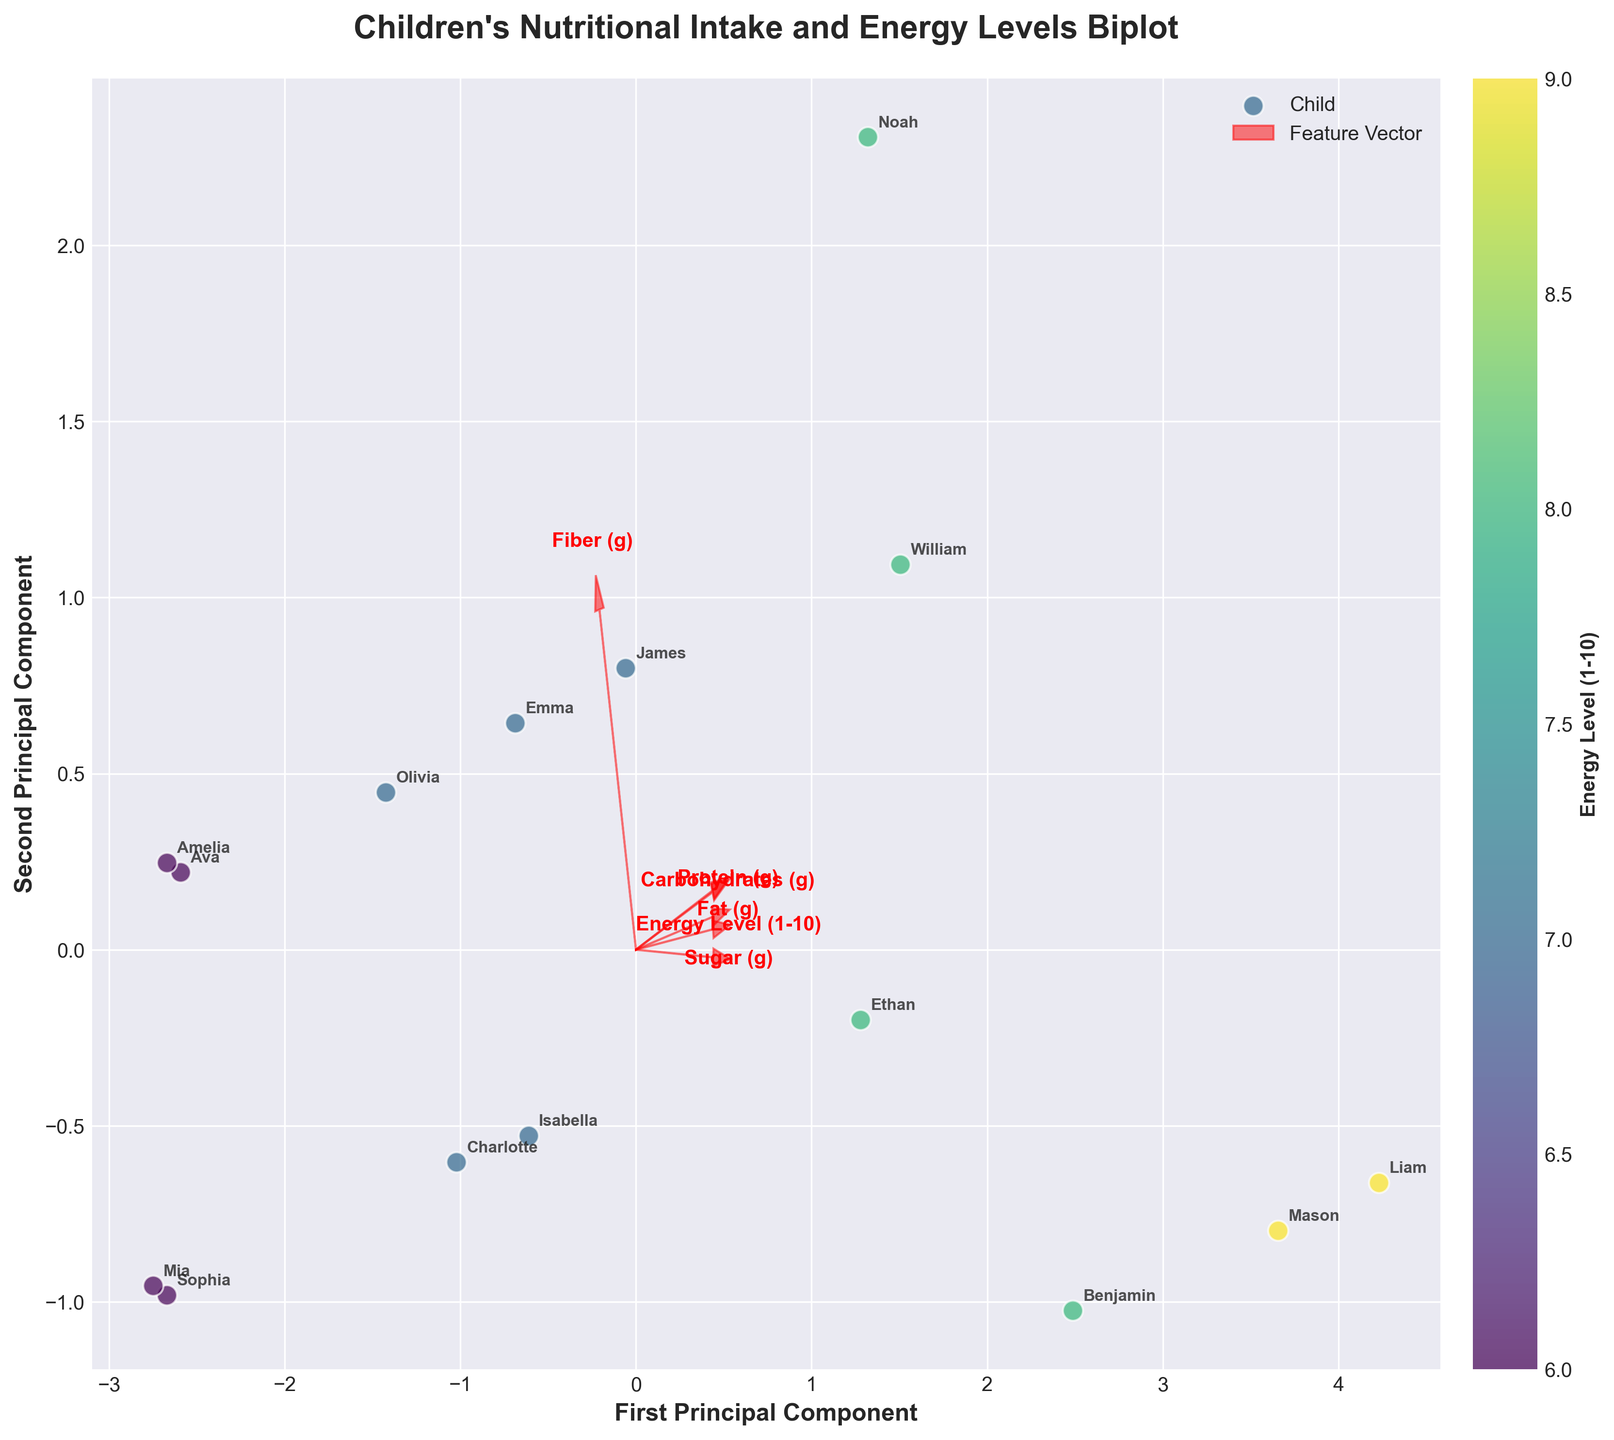How many children are represented in the plot? Count the number of individual data points (dots) in the biplot.
Answer: 15 What are the axes labels on the plot? The labels on the x-axis and y-axis can be read directly from the plot. They describe what each axis represents.
Answer: First Principal Component, Second Principal Component Which child's data point is furthest to the right on the plot? Locate the data point positioned furthest to the right along the x-axis (First Principal Component).
Answer: Liam Which feature has the longest vector (arrow) on the biplot? Compare the lengths of the arrows representing each feature. The longest arrow indicates the strongest variance explained by that feature.
Answer: Carbohydrates (g) Does sugar intake seem strongly associated with energy levels? Observe the direction and length of the arrow representing sugar intake in relation to the clustering of data points with high energy levels (indicated by color).
Answer: Yes Which two features seem to be most closely aligned in their direction on the biplot? Identify arrows that point in similar directions, indicating a strong relationship between those features.
Answer: Protein (g) and Fat (g) Are children with higher energy levels clustered together in the plot? Look at the data points with colors representing higher energy levels and see if they appear close to each other on the plot.
Answer: Yes What is the spread of children’s data points along the first principal component? Measure how much the data points are spread out along the x-axis (First Principal Component).
Answer: Wide spread Based on the biplot, which child should have a balanced intake of carbohydrates, protein, and fat for higher energy levels? Identify children whose data points are positioned so that the arrows for carbohydrates, protein, and fat point towards them and who also have high energy levels.
Answer: Noah and William Which nutrient seems to have the least influence on energy levels according to the biplot? Look at the length and direction of the arrow representing each nutrient, and identify the one with the shortest arrow and least correlation with energy level clustering.
Answer: Fiber (g) 